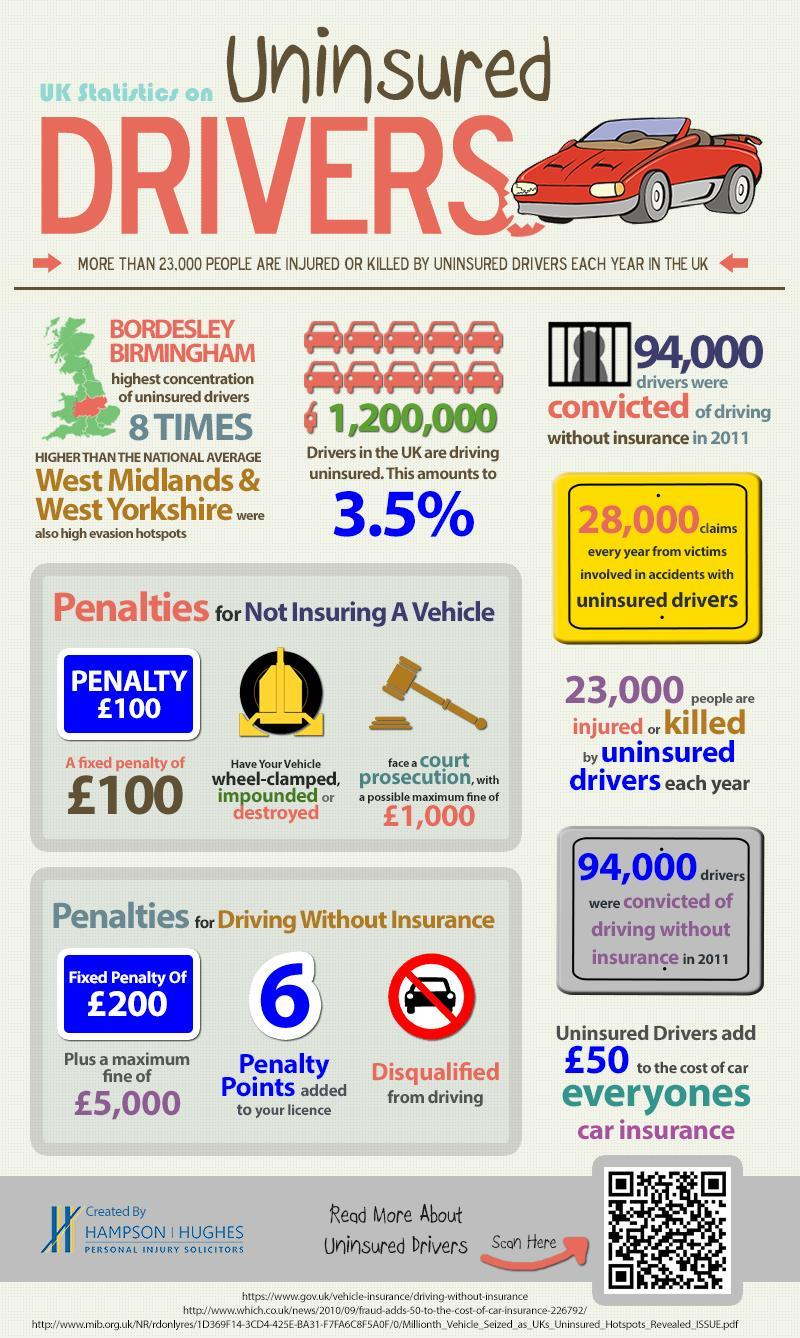What is the fixed penalty for not insuring a vehicle in UK in 2011?
Answer the question with a short phrase. £100 What is the maximum fine for driving without licence in UK in 2011? £5,000 What percentage of drivers in the UK are driving uninsured in 2011? 3.5% How many penalty points were added to the licence if the drivers in UK are convicted of driving without licence in 2011? 6 How many drivers in UK were convicted of driving without insurance in 2011? 94,000 